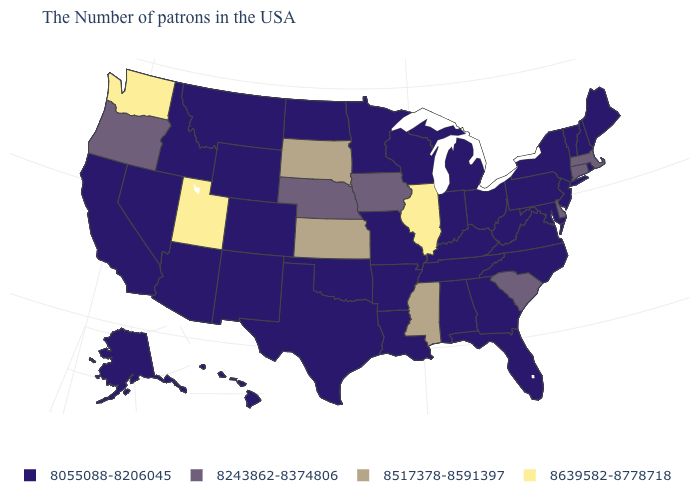What is the value of New York?
Give a very brief answer. 8055088-8206045. Name the states that have a value in the range 8055088-8206045?
Give a very brief answer. Maine, Rhode Island, New Hampshire, Vermont, New York, New Jersey, Maryland, Pennsylvania, Virginia, North Carolina, West Virginia, Ohio, Florida, Georgia, Michigan, Kentucky, Indiana, Alabama, Tennessee, Wisconsin, Louisiana, Missouri, Arkansas, Minnesota, Oklahoma, Texas, North Dakota, Wyoming, Colorado, New Mexico, Montana, Arizona, Idaho, Nevada, California, Alaska, Hawaii. Among the states that border Colorado , does Utah have the highest value?
Quick response, please. Yes. Name the states that have a value in the range 8243862-8374806?
Keep it brief. Massachusetts, Connecticut, Delaware, South Carolina, Iowa, Nebraska, Oregon. Does Wisconsin have the lowest value in the USA?
Write a very short answer. Yes. What is the value of Texas?
Answer briefly. 8055088-8206045. Among the states that border New York , does New Jersey have the lowest value?
Keep it brief. Yes. What is the value of California?
Answer briefly. 8055088-8206045. What is the lowest value in states that border Utah?
Write a very short answer. 8055088-8206045. Name the states that have a value in the range 8639582-8778718?
Quick response, please. Illinois, Utah, Washington. What is the value of New Mexico?
Keep it brief. 8055088-8206045. What is the value of Pennsylvania?
Answer briefly. 8055088-8206045. Does Oklahoma have the same value as South Carolina?
Short answer required. No. What is the lowest value in the Northeast?
Write a very short answer. 8055088-8206045. Name the states that have a value in the range 8639582-8778718?
Write a very short answer. Illinois, Utah, Washington. 